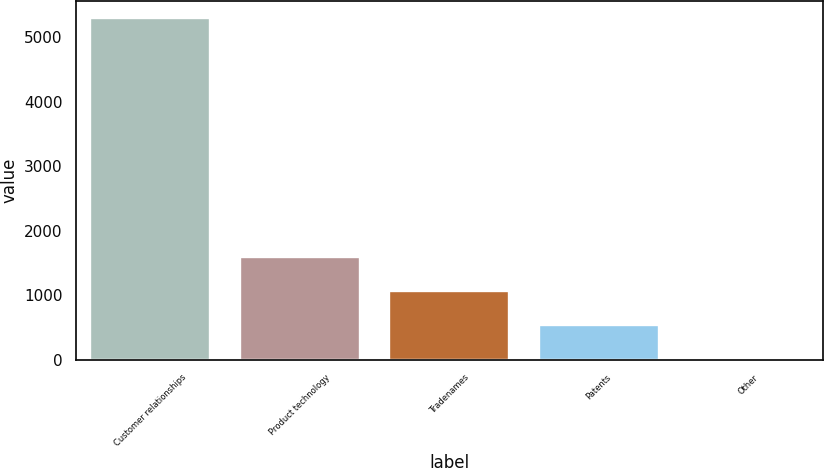Convert chart. <chart><loc_0><loc_0><loc_500><loc_500><bar_chart><fcel>Customer relationships<fcel>Product technology<fcel>Tradenames<fcel>Patents<fcel>Other<nl><fcel>5286.5<fcel>1595.75<fcel>1068.5<fcel>541.25<fcel>14<nl></chart> 